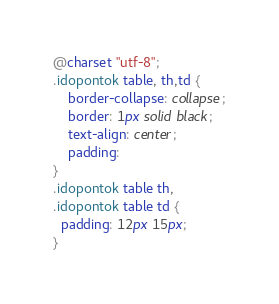<code> <loc_0><loc_0><loc_500><loc_500><_CSS_>
@charset "utf-8";
.idopontok table, th,td {
    border-collapse: collapse;
    border: 1px solid black;
    text-align: center;
    padding:
}
.idopontok table th,
.idopontok table td {
  padding: 12px 15px;
}</code> 